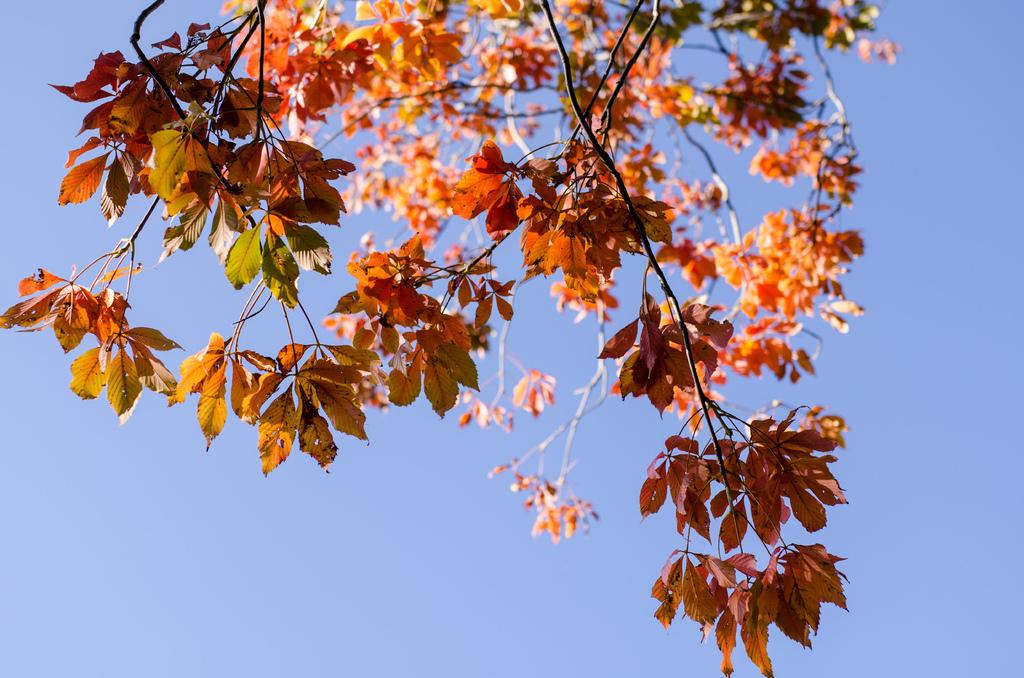What type of plant is in the image? The plant in the image has orange-colored leaves. What can be seen in the background of the image? There is sky visible in the background of the image. How does the plant use its thumb to perform magic in the image? Plants do not have thumbs or the ability to perform magic, so this scenario is not present in the image. 